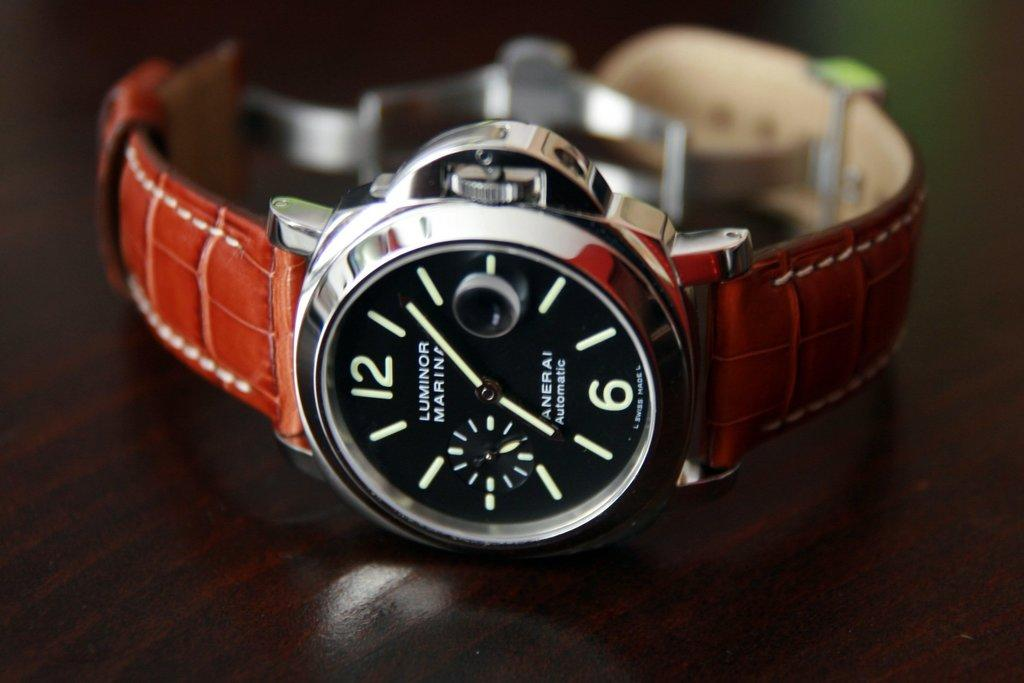<image>
Relay a brief, clear account of the picture shown. A Luminor watch that's been displayed on a table 